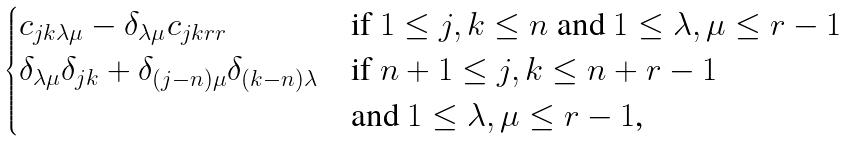Convert formula to latex. <formula><loc_0><loc_0><loc_500><loc_500>\begin{cases} c _ { j k \lambda \mu } - \delta _ { \lambda \mu } c _ { j k r r } & \text {if $1\leq j,k\leq n$ and $1\leq\lambda,\mu\leq r-1$} \\ \delta _ { \lambda \mu } \delta _ { j k } + \delta _ { ( j - n ) \mu } \delta _ { ( k - n ) \lambda } & \text {if $n+1\leq j,k\leq n+r-1$} \\ & \text {and $1\leq\lambda,\mu\leq r-1$,} \end{cases}</formula> 